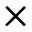<formula> <loc_0><loc_0><loc_500><loc_500>\times</formula> 